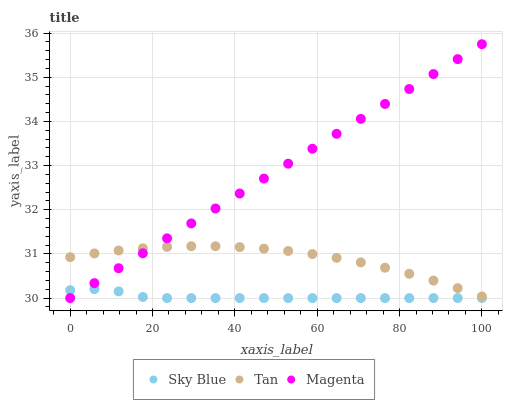Does Sky Blue have the minimum area under the curve?
Answer yes or no. Yes. Does Magenta have the maximum area under the curve?
Answer yes or no. Yes. Does Tan have the minimum area under the curve?
Answer yes or no. No. Does Tan have the maximum area under the curve?
Answer yes or no. No. Is Magenta the smoothest?
Answer yes or no. Yes. Is Sky Blue the roughest?
Answer yes or no. Yes. Is Tan the smoothest?
Answer yes or no. No. Is Tan the roughest?
Answer yes or no. No. Does Sky Blue have the lowest value?
Answer yes or no. Yes. Does Tan have the lowest value?
Answer yes or no. No. Does Magenta have the highest value?
Answer yes or no. Yes. Does Tan have the highest value?
Answer yes or no. No. Is Sky Blue less than Tan?
Answer yes or no. Yes. Is Tan greater than Sky Blue?
Answer yes or no. Yes. Does Magenta intersect Tan?
Answer yes or no. Yes. Is Magenta less than Tan?
Answer yes or no. No. Is Magenta greater than Tan?
Answer yes or no. No. Does Sky Blue intersect Tan?
Answer yes or no. No. 